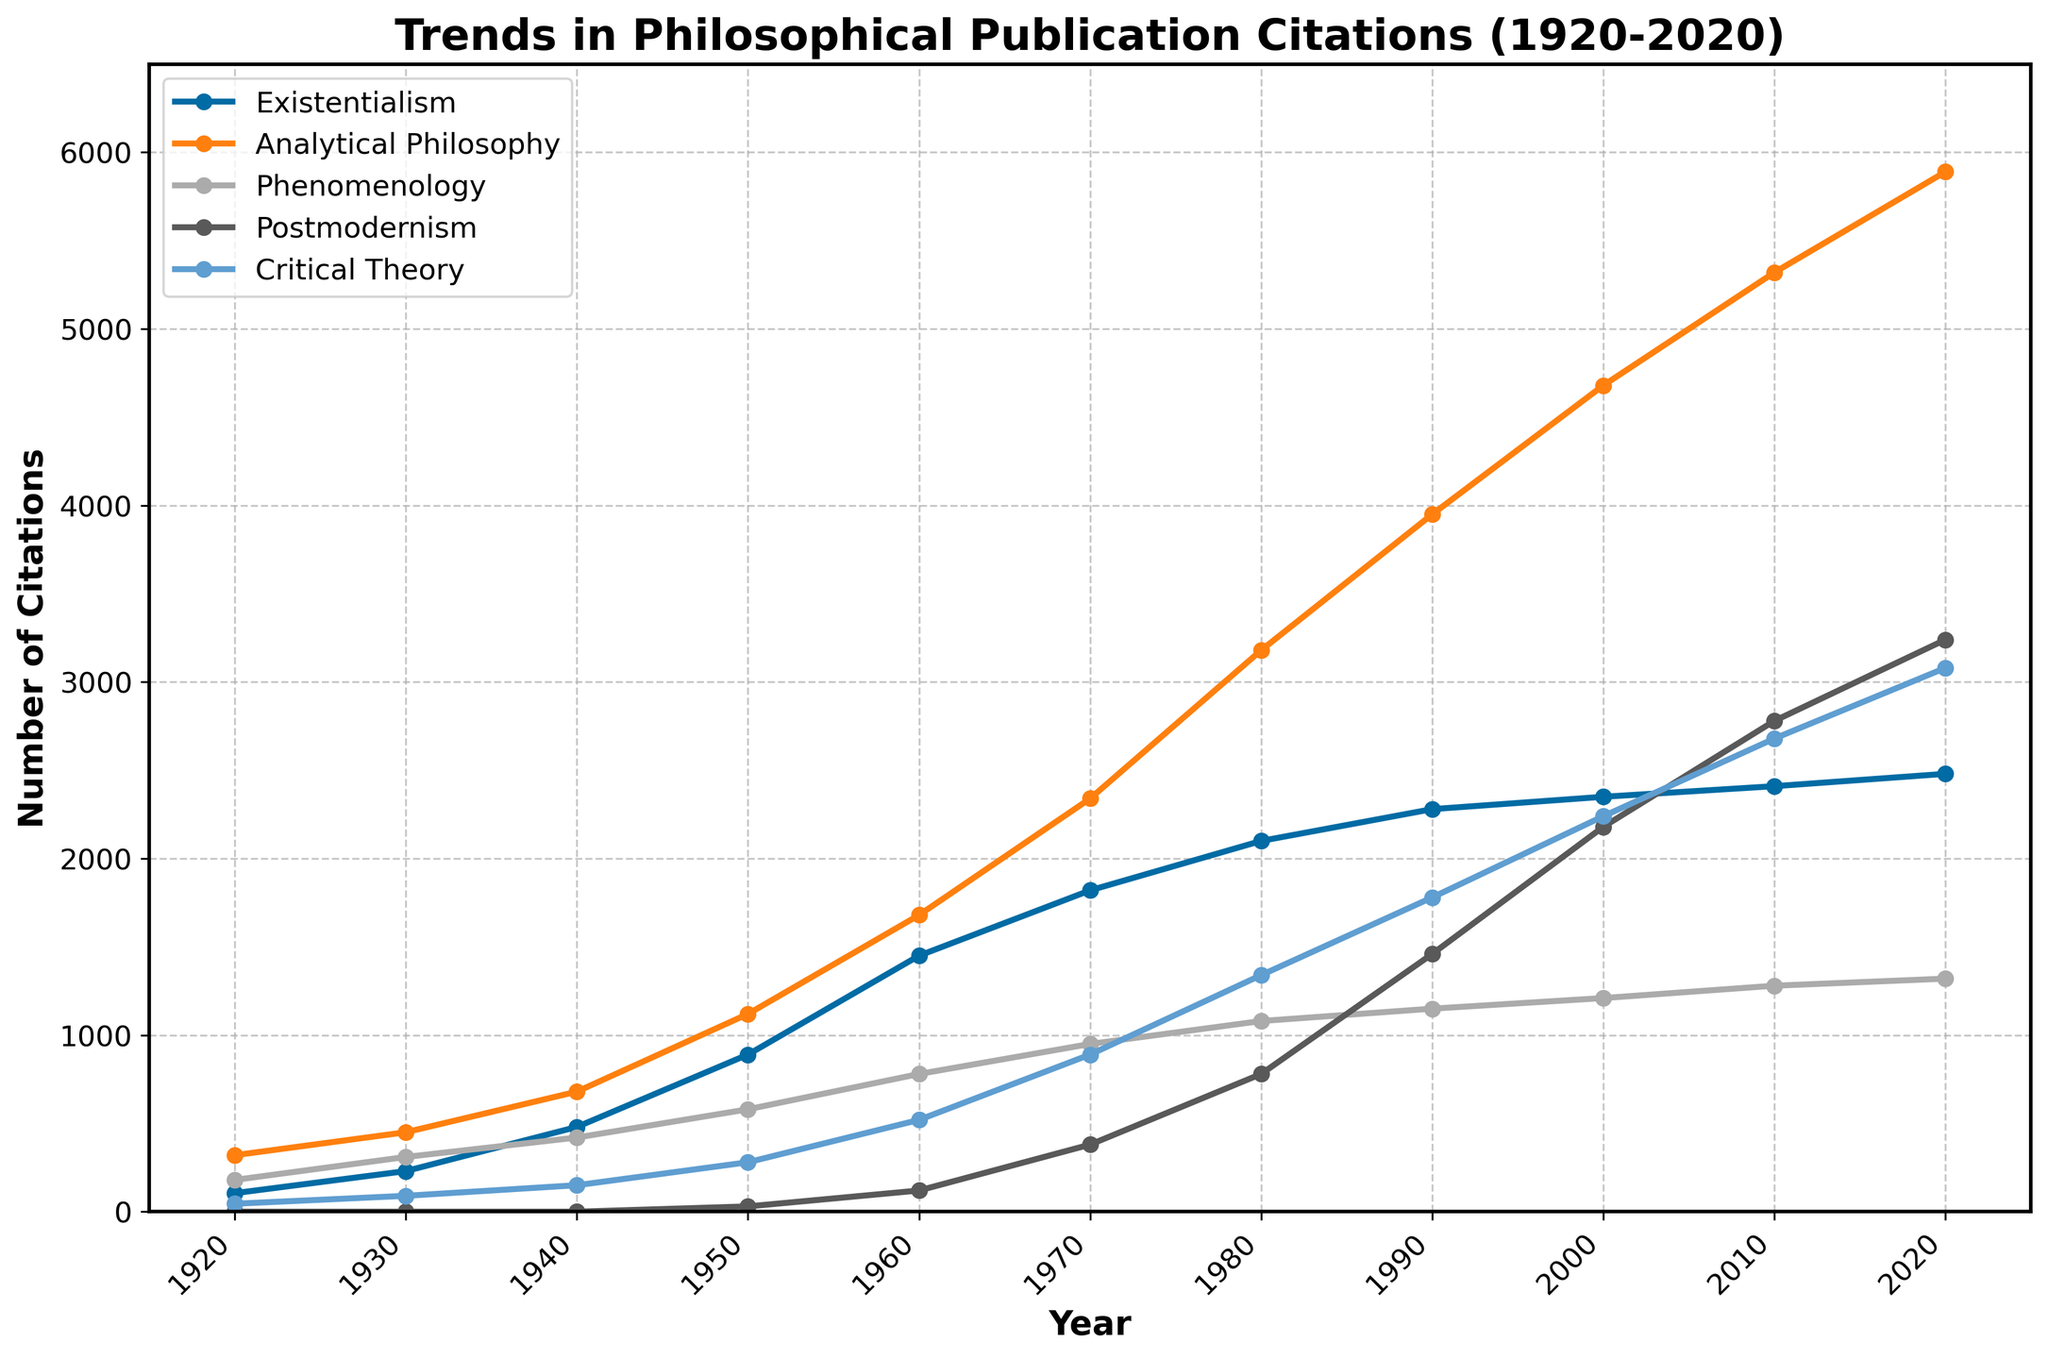What year did Postmodernism start to receive citations? To determine when Postmodernism citations began, look at the plot and identify the first year with a non-zero value for the Postmodernism line. This is in 1950.
Answer: 1950 Which school of thought experienced the steepest increase in citations between 1960 and 1970? By observing the slopes of the lines between 1960 and 1970, Analytical Philosophy has the steepest slope, showing the largest increase in citations during this period.
Answer: Analytical Philosophy What is the combined number of citations for Phenomenology and Critical Theory in 1980? In 1980, the Phenomenology citations are 1080 and Critical Theory citations are 1340. Adding these together gives 1080 + 1340 = 2420.
Answer: 2420 Which philosophical school had the highest number of citations in 2020? By looking at the endpoint of each line in 2020, Analytical Philosophy has the highest value at 5890.
Answer: Analytical Philosophy How did the number of citations for Existentialism change from 1920 to 2020? Comparing the starting and ending points of the Existentialism line from 1920 (105 citations) to 2020 (2480 citations), the number of citations increased by 2480 - 105 = 2375.
Answer: 2375 Between 1930 and 1940, which two schools of thought had the most similar increase in citations? Existentialism increased from 230 to 480 (an increase of 250), and Phenomenology increased from 310 to 420 (an increase of 110). Analytical Philosophy increased from 450 to 680 (an increase of 230), which is most similar to Existentialism's increase in this period.
Answer: Existentialism and Analytical Philosophy What is the approximate average yearly growth in citations for Critical Theory between 1950 and 2020? From 1950 (280 citations) to 2020 (3080 citations), the total increase is 3080 - 280 = 2800 over a span of 70 years, giving an average yearly growth of 2800 / 70 ≈ 40 citations.
Answer: 40 Which school of thought had the smallest increase in citations from 2010 to 2020? By comparing the differences for each school: Existentialism (70), Analytical Philosophy (570), Phenomenology (40), Postmodernism (460), Critical Theory (400), Phenomenology had the smallest increase.
Answer: Phenomenology 